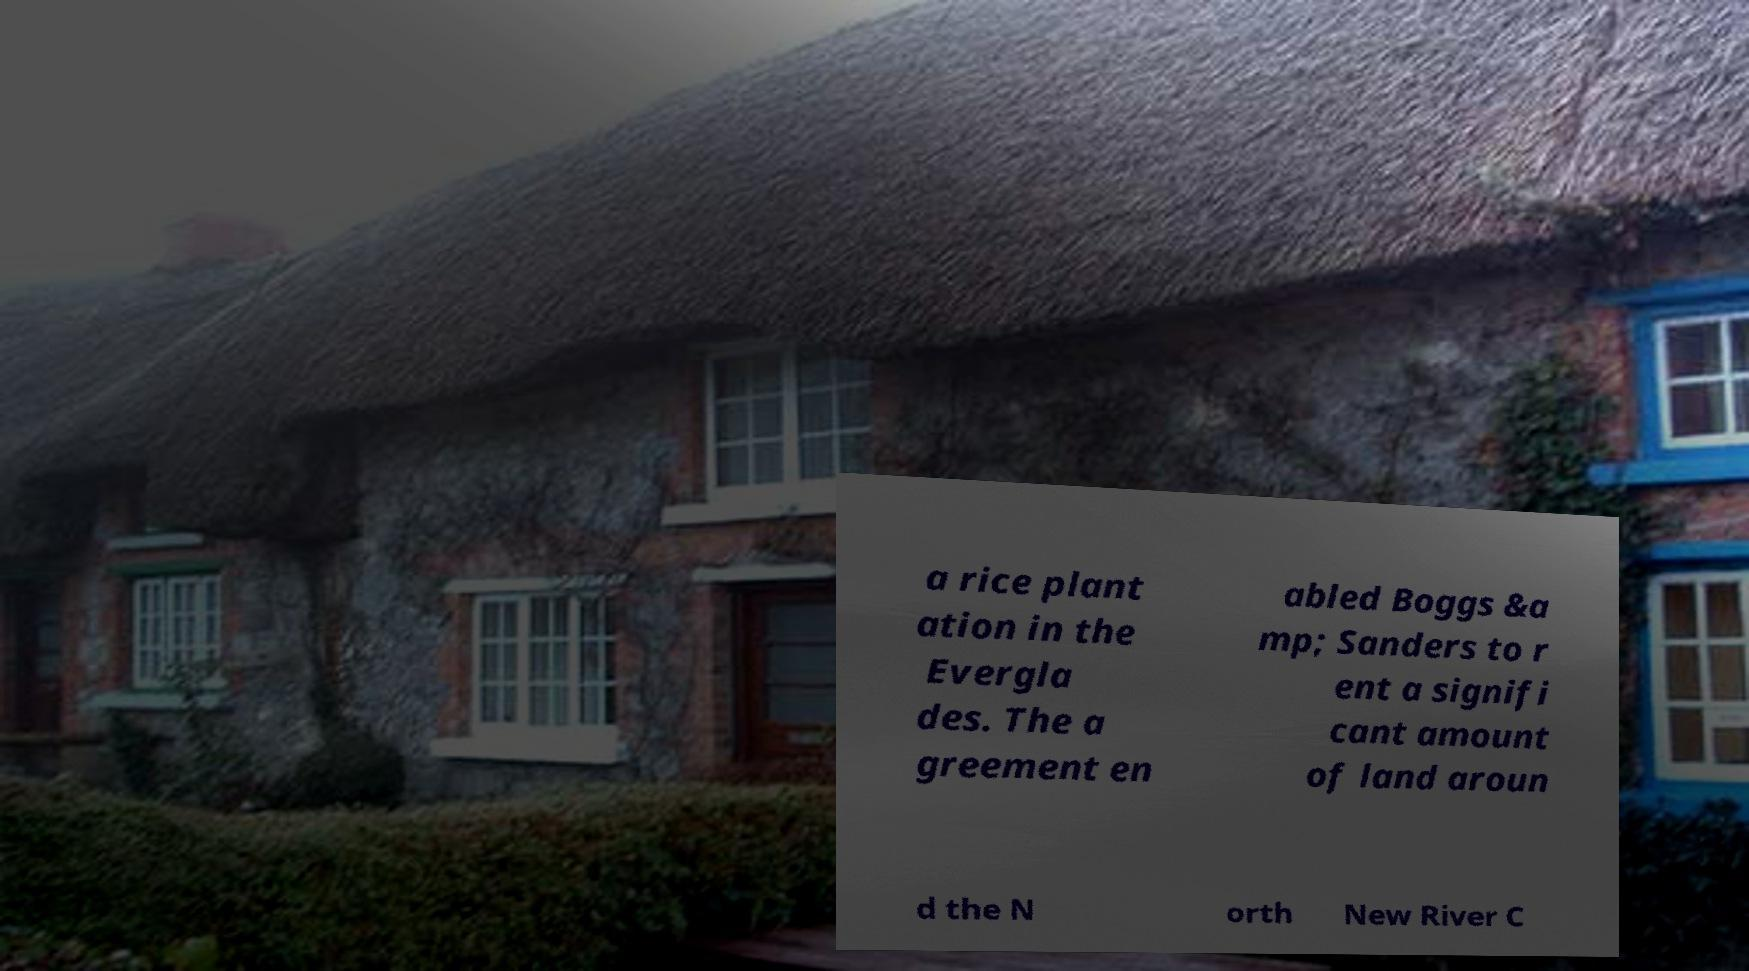Can you accurately transcribe the text from the provided image for me? a rice plant ation in the Evergla des. The a greement en abled Boggs &a mp; Sanders to r ent a signifi cant amount of land aroun d the N orth New River C 